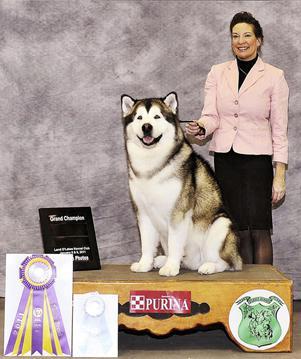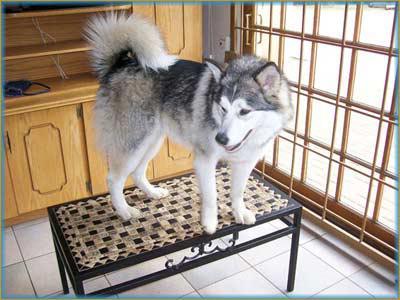The first image is the image on the left, the second image is the image on the right. Given the left and right images, does the statement "There is at least one dog on top of a table." hold true? Answer yes or no. Yes. The first image is the image on the left, the second image is the image on the right. Assess this claim about the two images: "The right image shows a husky dog perched atop a rectangular table in front of something with criss-crossing lines.". Correct or not? Answer yes or no. Yes. 